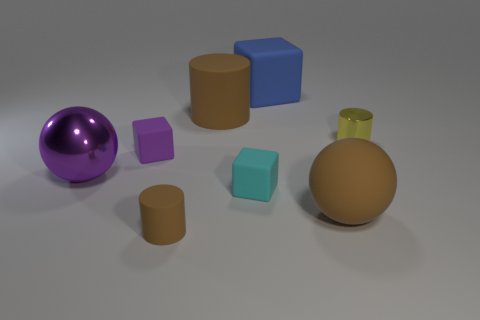Add 2 big brown cylinders. How many objects exist? 10 Subtract all small purple blocks. How many blocks are left? 2 Subtract all balls. How many objects are left? 6 Subtract 3 cylinders. How many cylinders are left? 0 Subtract all red balls. Subtract all brown cylinders. How many balls are left? 2 Subtract all yellow balls. How many gray cubes are left? 0 Subtract all tiny objects. Subtract all tiny purple cubes. How many objects are left? 3 Add 7 brown spheres. How many brown spheres are left? 8 Add 3 brown shiny blocks. How many brown shiny blocks exist? 3 Subtract all brown balls. How many balls are left? 1 